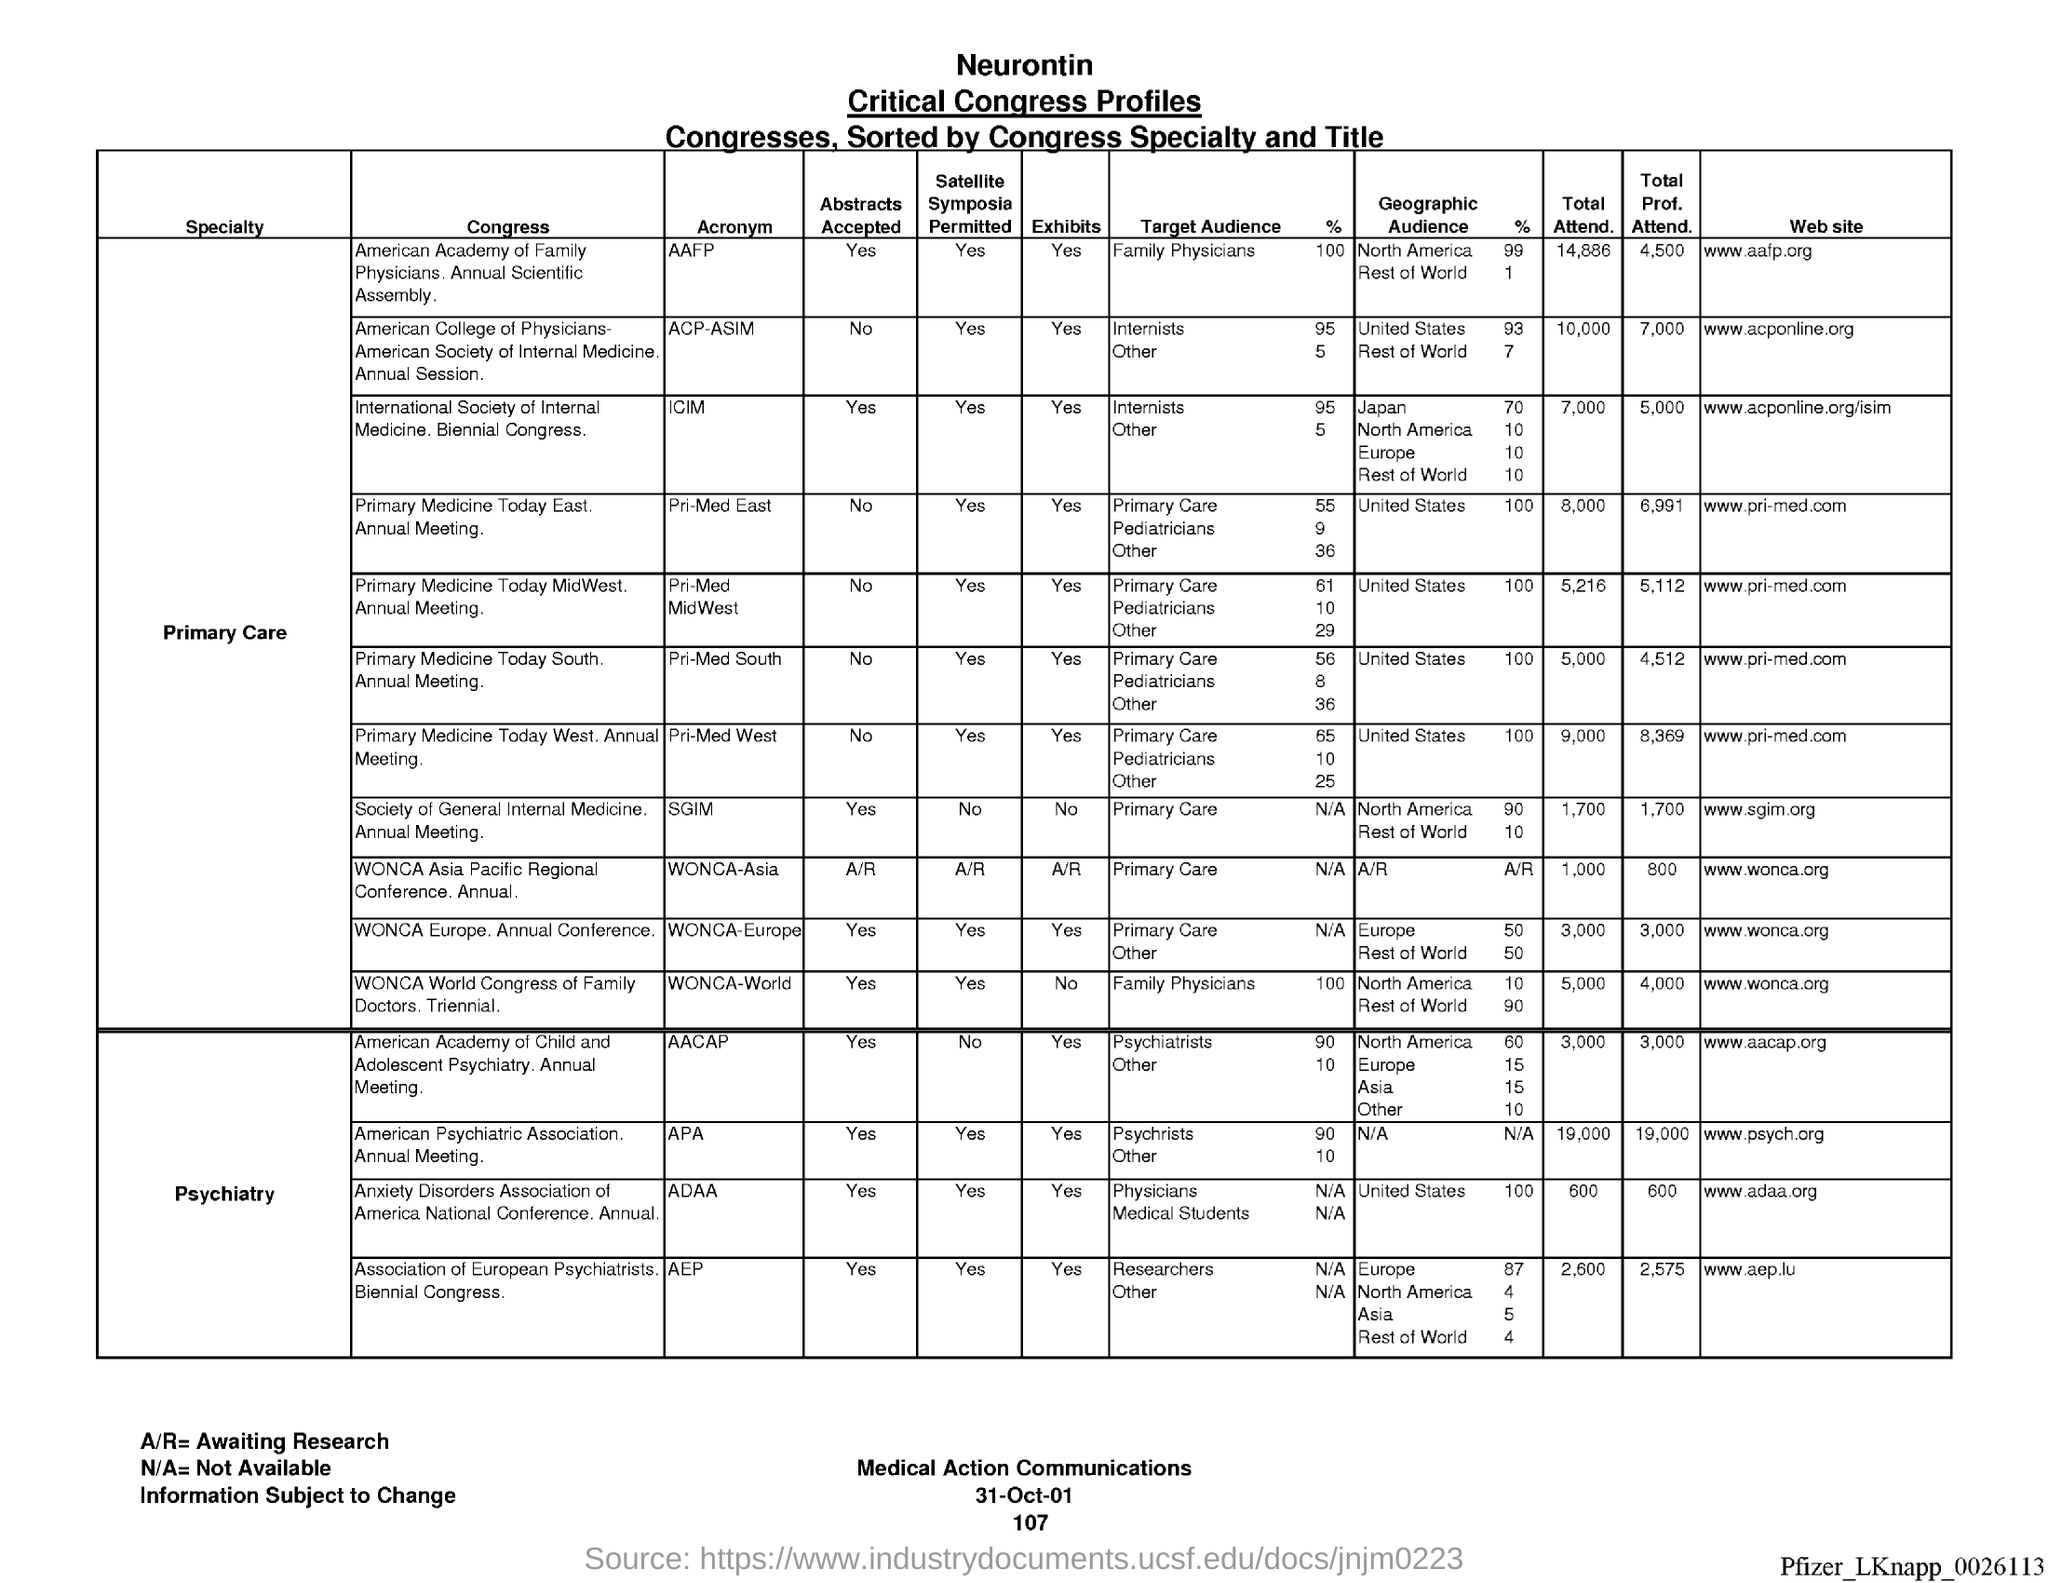What is the Total Attend. for AAFP?
Give a very brief answer. 14,886. What is the Total Attend. for ACP-ASIV?
Your answer should be compact. 10,000. What is the Total Attend. for ICIM?
Your answer should be compact. 7,000. What is the Total Attend. for Pri-med East?
Ensure brevity in your answer.  8,000. What is the Total Attend. for Pri-med Midwest?
Provide a short and direct response. 5,216. What is the Total Attend. for Pri-med South?
Offer a terse response. 5,000. What is the Total Attend. for Pri-med west?
Your response must be concise. 9,000. What is the Total Attend. for SGIM?
Your answer should be compact. 1,700. What is the Total Attend. for AACAP?
Offer a terse response. 3,000. What is the Total Attend. for APA?
Provide a short and direct response. 19,000. 